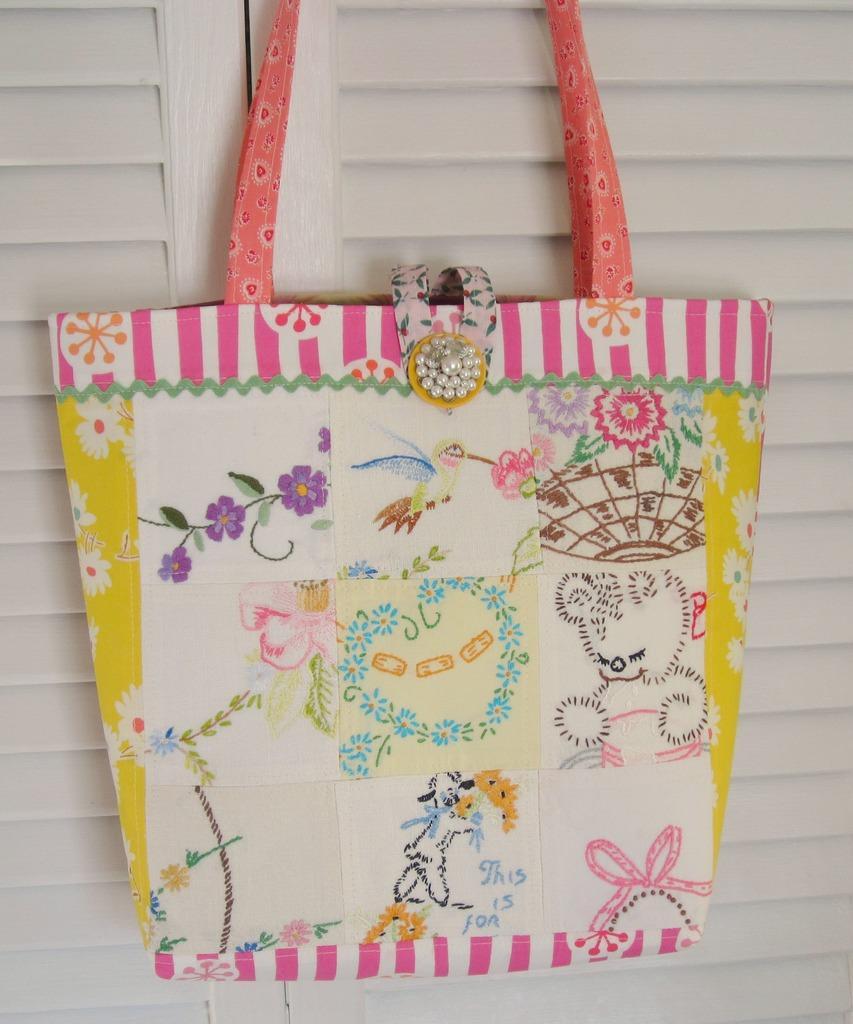Describe this image in one or two sentences. In the picture is a bag there are a lot of crafts on the bag, it is of multi color there is a pink color handle,this bag is hanged to a door, door is of white color. 